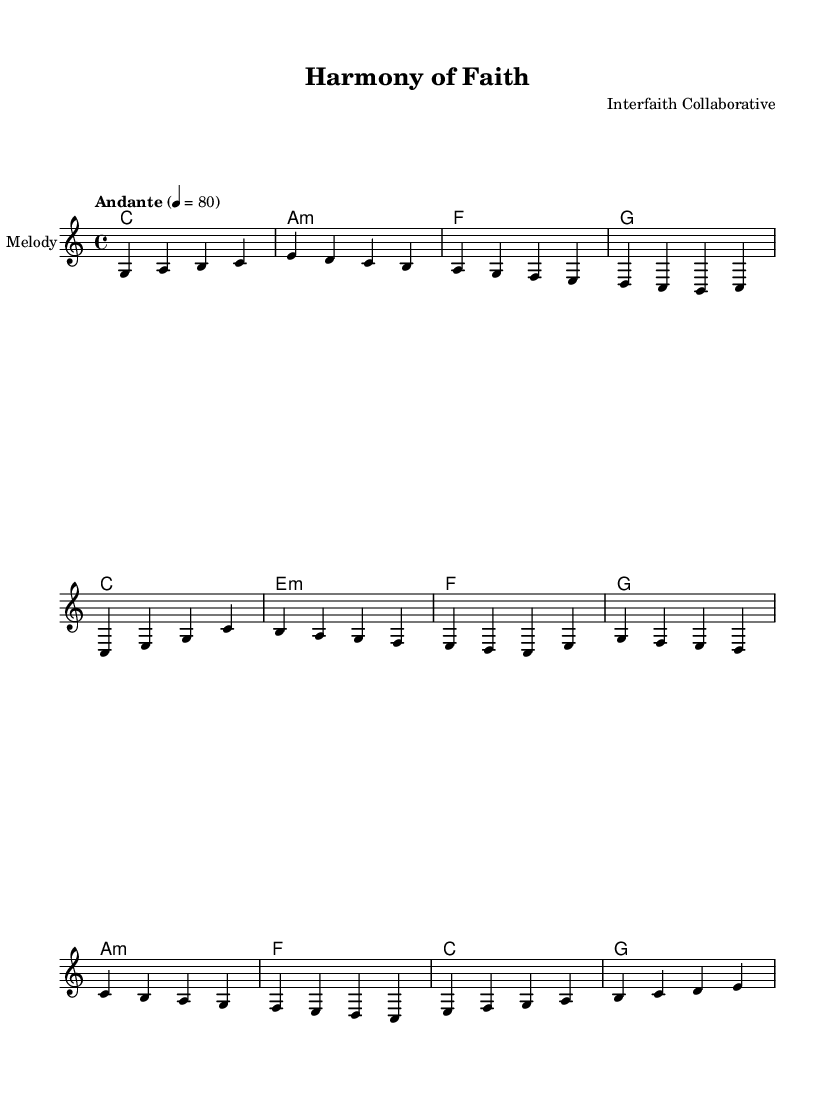What is the key signature of this music? The key signature is C major, which has no sharps or flats indicated on the staff.
Answer: C major What is the time signature of this piece? The time signature shown at the beginning of the score is 4/4, indicating four beats per measure.
Answer: 4/4 What is the tempo marking for this piece? The tempo marking is "Andante," which indicates a moderately slow pace, usually around 76 to 108 beats per minute.
Answer: Andante What is the first note of the melody? The first note in the melody is G, as indicated in the opening measure of the sheet music.
Answer: G In which section of the piece is the phrase "One voice, one heart" located? This phrase appears in the chorus section, as identified by its placement in the lyrics matched to the melody.
Answer: Chorus What chord follows the A minor chord in the harmonies? After the A minor chord, the next chord specified is F, as seen in the sequence of harmonies.
Answer: F How many musical sections are included in this sheet music? There are three distinct sections in the piece: Intro, Verse, and Chorus, as outlined in the structure presented.
Answer: Three 